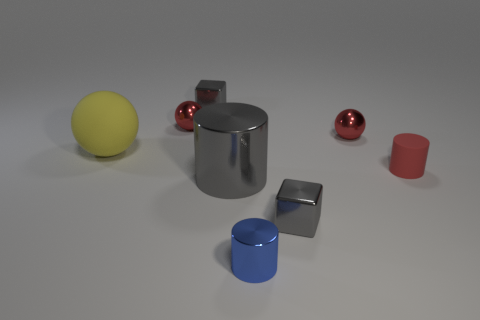There is a matte thing on the right side of the small blue cylinder; what is its shape?
Make the answer very short. Cylinder. How many objects are either large matte things or rubber objects on the left side of the blue metallic object?
Ensure brevity in your answer.  1. Is the material of the gray cylinder the same as the tiny blue thing?
Your response must be concise. Yes. Are there an equal number of small gray metal cubes that are in front of the tiny blue shiny thing and rubber cylinders that are right of the rubber cylinder?
Your response must be concise. Yes. What number of tiny red metallic objects are to the left of the tiny blue thing?
Offer a terse response. 1. What number of objects are tiny red objects or big red shiny spheres?
Keep it short and to the point. 3. What number of objects are the same size as the blue shiny cylinder?
Ensure brevity in your answer.  5. What shape is the big object that is on the left side of the tiny block to the left of the blue object?
Your response must be concise. Sphere. Are there fewer blue metal cylinders than large blue metallic things?
Provide a short and direct response. No. What color is the shiny block that is behind the large gray cylinder?
Offer a very short reply. Gray. 